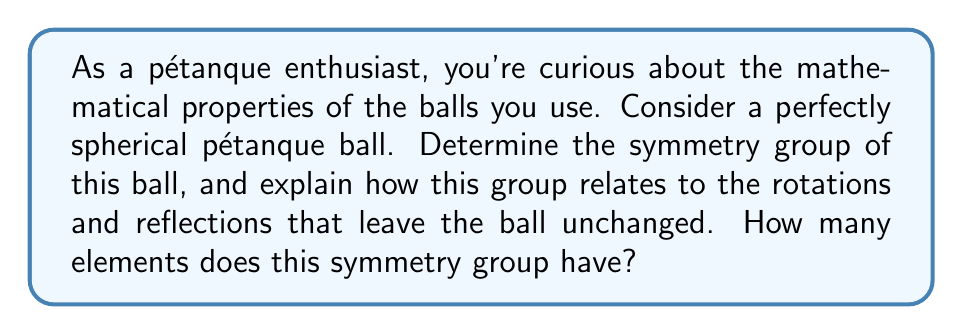Solve this math problem. To determine the symmetry group of a spherical pétanque ball, we need to consider all the transformations that leave the ball unchanged. For a perfect sphere, these transformations include rotations around any axis passing through the center of the sphere and reflections across any plane passing through the center.

1. Rotations:
   The set of all rotations in 3D space forms the special orthogonal group $SO(3)$. This group is continuous and has infinitely many elements.

2. Reflections:
   Adding reflections to the rotations gives us the orthogonal group $O(3)$, which includes both proper and improper rotations.

The symmetry group of a sphere is isomorphic to $O(3)$, which is the full orthogonal group in three dimensions. This group can be described as:

$$ O(3) = \{A \in \mathbb{R}^{3\times3} : A^T A = AA^T = I, \det(A) = \pm1\} $$

Where $A$ is a $3\times3$ real matrix, $A^T$ is its transpose, $I$ is the identity matrix, and $\det(A)$ is the determinant of $A$.

The group $O(3)$ has some important properties:
1. It's a Lie group, which means it's both a group and a smooth manifold.
2. It has two connected components: $SO(3)$ (rotations) and $O(3) \setminus SO(3)$ (reflections followed by rotations).
3. Its dimension as a Lie group is 3, corresponding to the three degrees of freedom in specifying a rotation in 3D space.

The number of elements in $O(3)$ is infinite, as there are infinitely many possible rotations and reflections that can be applied to a sphere while leaving it unchanged.

In the context of pétanque, this means that no matter how you rotate or flip the ball, it will always look the same, which is crucial for fair play in the game.
Answer: The symmetry group of a spherical pétanque ball is isomorphic to $O(3)$, the orthogonal group in three dimensions. This group has infinitely many elements. 